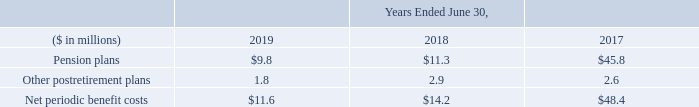Net Pension Expense
Net pension expense, as we define it below, includes the net periodic benefit costs related to both our pension and other postretirement plans. The net periodic benefit costs are determined annually based on beginning of year balances and are recorded ratably throughout the fiscal year, unless a significant re-measurement event occurs. The following is a summary of the net periodic benefit costs for the years ended June 30, 2019, 2018 and 2017:
In September 2016, we announced changes to retirement plans we offer to certain employees. Benefits accrued to eligible participants of our largest qualified defined benefit pension plan and certain non-qualified pension plans were frozen effective December 31, 2016. Approximately 1,900 affected employees were transitioned to the Company’s 401(k) plan that has been in effect for eligible employees since 2012, when the pension plan was closed to new entrants. We recognized the plan freeze during fiscal year 2017 as a curtailment, since it eliminated the accrual for a significant number of participants for all of their future services. We also made a voluntary pension contribution of $100.0 million to the affected plan in October 2016.
The service cost component of net pension expense represents the estimated cost of future pension liabilities earned associated with active employees. The pension earnings, interest and deferrals (“pension EID”) is comprised of the expected return on plan assets, interest costs on the projected benefit obligations of the plans and amortization of actuarial gains and losses and prior service costs.
What does net pension expense include? Includes the net periodic benefit costs related to both our pension and other postretirement plans. When was the changes to retirement plans offered to certain employees announced? In september 2016. In which years was Net Pension Expense calculated? 2019, 2018, 2017. In which year was Other postretirement plans largest? 2.9>2.6>1.8
Answer: 2018. What was the change in Pension Plans in 2019 from 2018?
Answer scale should be: million. 9.8-11.3
Answer: -1.5. What was the percentage change in Pension Plans in 2019 from 2018?
Answer scale should be: percent. (9.8-11.3)/11.3
Answer: -13.27. 